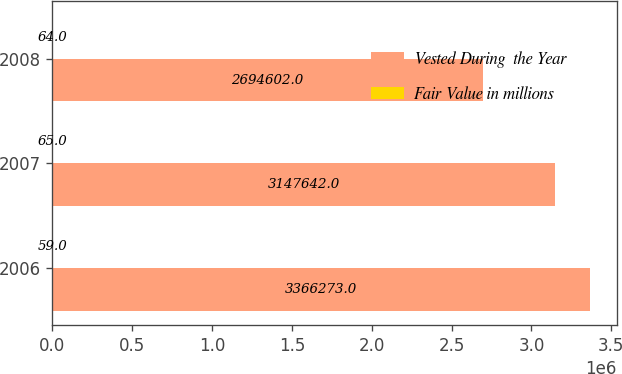Convert chart. <chart><loc_0><loc_0><loc_500><loc_500><stacked_bar_chart><ecel><fcel>2006<fcel>2007<fcel>2008<nl><fcel>Vested During  the Year<fcel>3.36627e+06<fcel>3.14764e+06<fcel>2.6946e+06<nl><fcel>Fair Value in millions<fcel>59<fcel>65<fcel>64<nl></chart> 